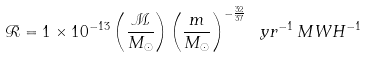<formula> <loc_0><loc_0><loc_500><loc_500>\mathcal { R } = 1 \times 1 0 ^ { - 1 3 } \left ( \frac { \mathcal { M } } { M _ { \odot } } \right ) \left ( \frac { m } { M _ { \odot } } \right ) ^ { - \frac { 3 2 } { 3 7 } } \ y r ^ { - 1 } \, M W H ^ { - 1 }</formula> 